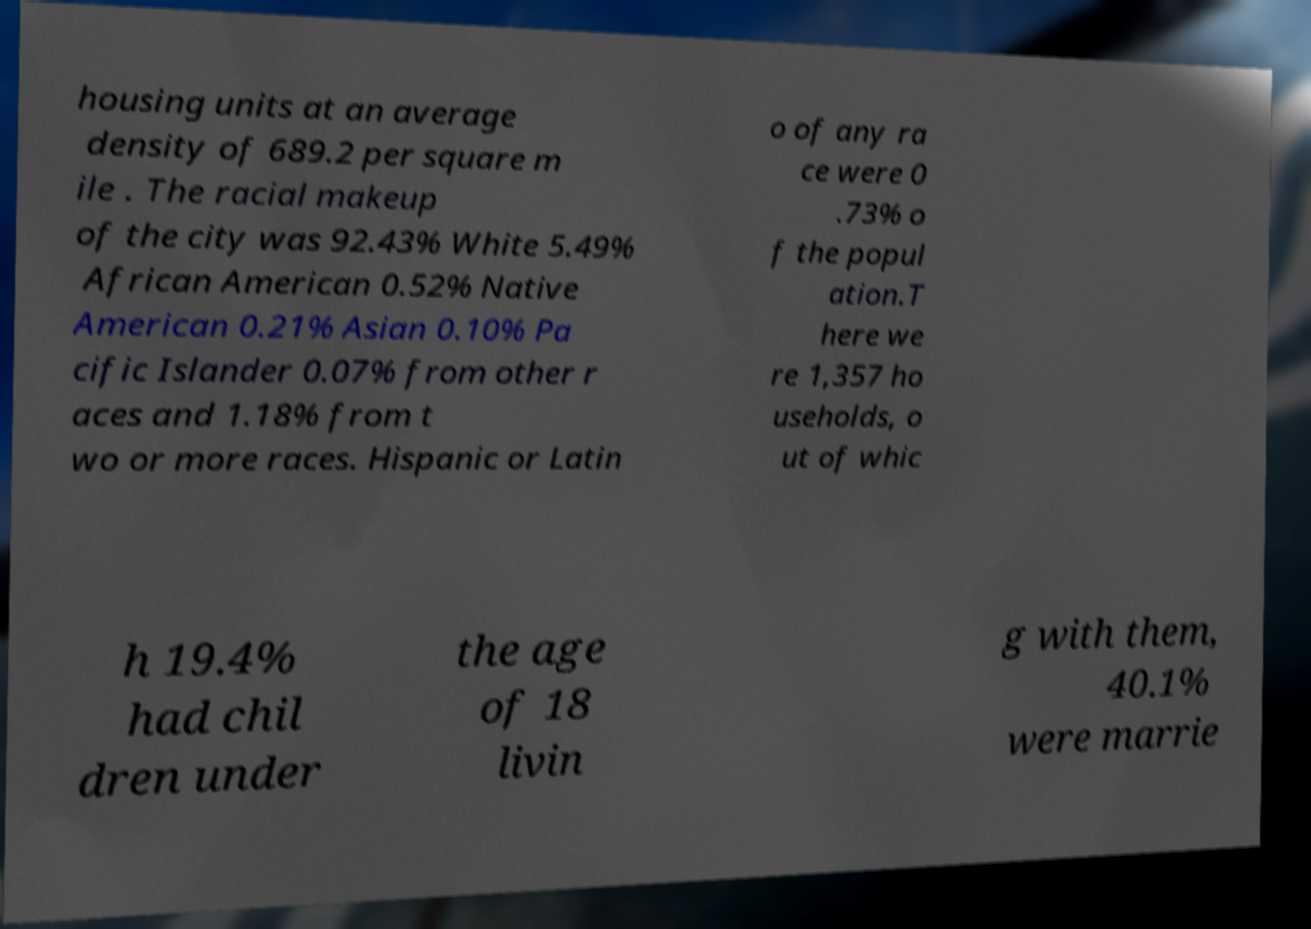Can you read and provide the text displayed in the image?This photo seems to have some interesting text. Can you extract and type it out for me? housing units at an average density of 689.2 per square m ile . The racial makeup of the city was 92.43% White 5.49% African American 0.52% Native American 0.21% Asian 0.10% Pa cific Islander 0.07% from other r aces and 1.18% from t wo or more races. Hispanic or Latin o of any ra ce were 0 .73% o f the popul ation.T here we re 1,357 ho useholds, o ut of whic h 19.4% had chil dren under the age of 18 livin g with them, 40.1% were marrie 